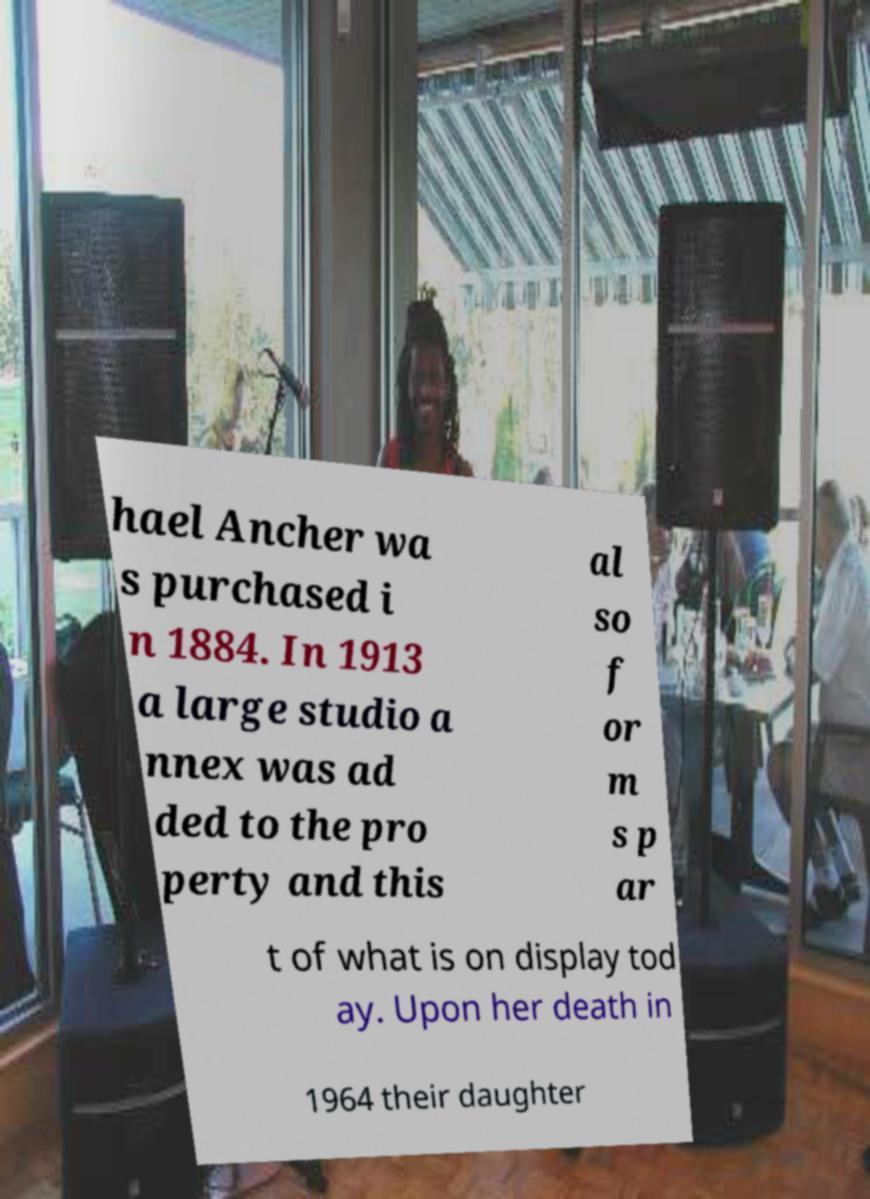Could you extract and type out the text from this image? hael Ancher wa s purchased i n 1884. In 1913 a large studio a nnex was ad ded to the pro perty and this al so f or m s p ar t of what is on display tod ay. Upon her death in 1964 their daughter 